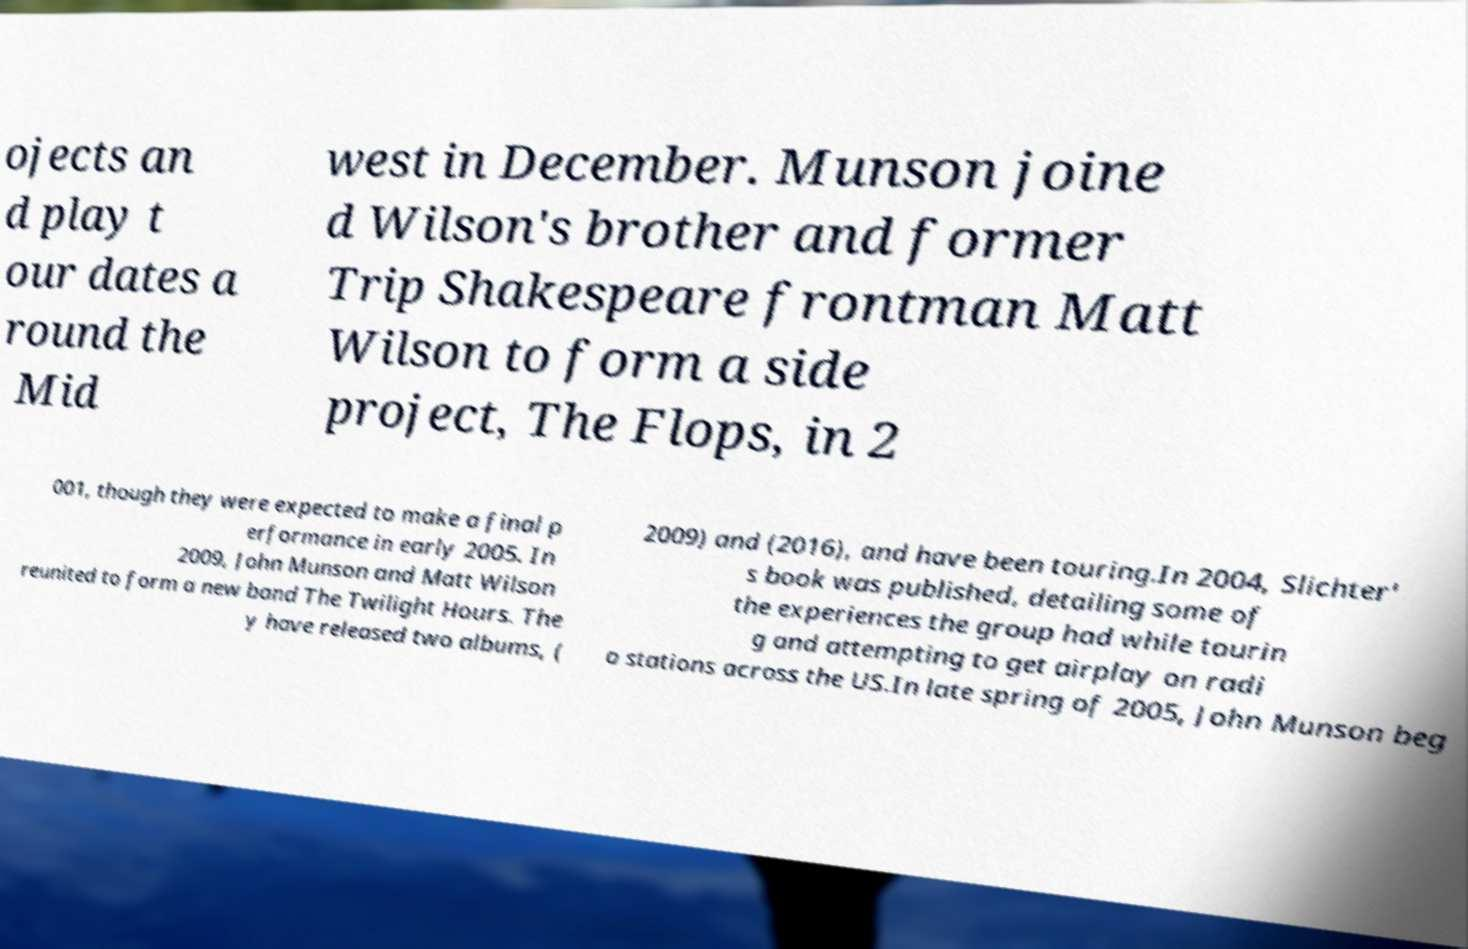Can you read and provide the text displayed in the image?This photo seems to have some interesting text. Can you extract and type it out for me? ojects an d play t our dates a round the Mid west in December. Munson joine d Wilson's brother and former Trip Shakespeare frontman Matt Wilson to form a side project, The Flops, in 2 001, though they were expected to make a final p erformance in early 2005. In 2009, John Munson and Matt Wilson reunited to form a new band The Twilight Hours. The y have released two albums, ( 2009) and (2016), and have been touring.In 2004, Slichter' s book was published, detailing some of the experiences the group had while tourin g and attempting to get airplay on radi o stations across the US.In late spring of 2005, John Munson beg 